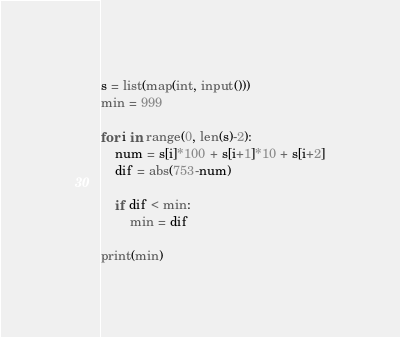<code> <loc_0><loc_0><loc_500><loc_500><_Python_>s = list(map(int, input()))
min = 999

for i in range(0, len(s)-2):
    num = s[i]*100 + s[i+1]*10 + s[i+2]
    dif = abs(753-num)
    
    if dif < min:
        min = dif
        
print(min)        </code> 